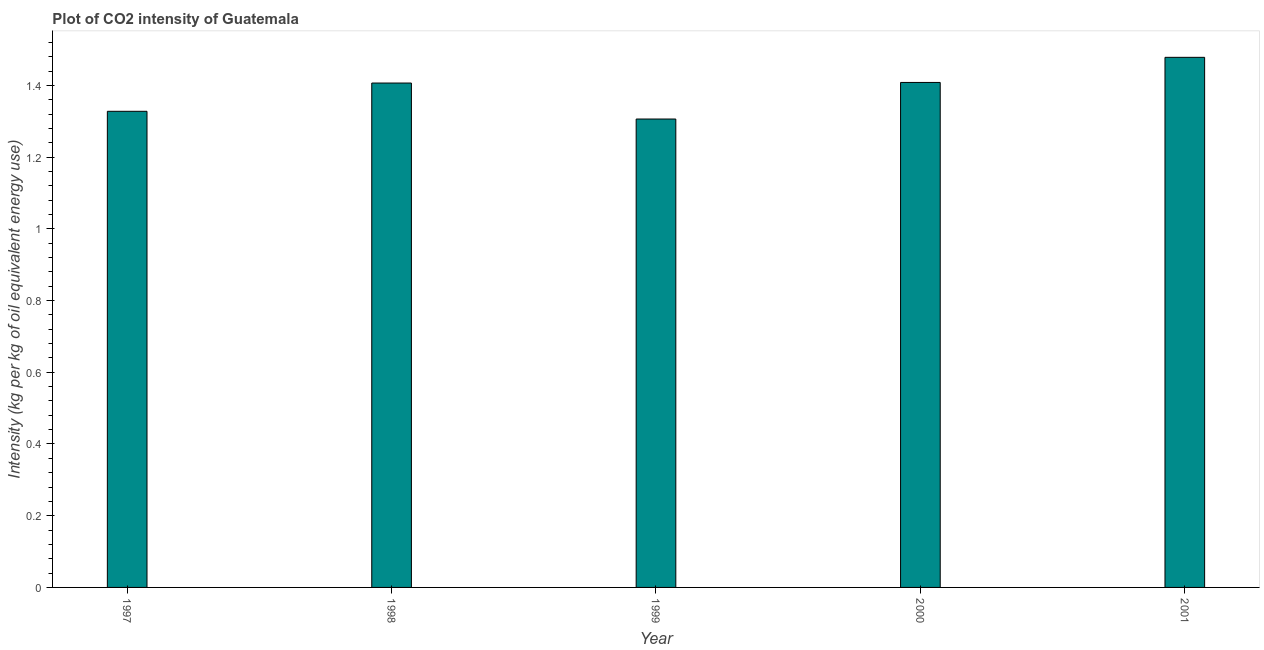Does the graph contain any zero values?
Provide a succinct answer. No. Does the graph contain grids?
Your answer should be compact. No. What is the title of the graph?
Your response must be concise. Plot of CO2 intensity of Guatemala. What is the label or title of the Y-axis?
Offer a very short reply. Intensity (kg per kg of oil equivalent energy use). What is the co2 intensity in 1997?
Ensure brevity in your answer.  1.33. Across all years, what is the maximum co2 intensity?
Your answer should be compact. 1.48. Across all years, what is the minimum co2 intensity?
Keep it short and to the point. 1.31. In which year was the co2 intensity maximum?
Provide a succinct answer. 2001. In which year was the co2 intensity minimum?
Provide a succinct answer. 1999. What is the sum of the co2 intensity?
Offer a very short reply. 6.93. What is the difference between the co2 intensity in 1998 and 2000?
Offer a terse response. -0. What is the average co2 intensity per year?
Your response must be concise. 1.39. What is the median co2 intensity?
Give a very brief answer. 1.41. In how many years, is the co2 intensity greater than 1.16 kg?
Offer a terse response. 5. Do a majority of the years between 2000 and 2001 (inclusive) have co2 intensity greater than 0.08 kg?
Make the answer very short. Yes. What is the ratio of the co2 intensity in 1998 to that in 2001?
Offer a very short reply. 0.95. What is the difference between the highest and the second highest co2 intensity?
Make the answer very short. 0.07. Is the sum of the co2 intensity in 2000 and 2001 greater than the maximum co2 intensity across all years?
Make the answer very short. Yes. What is the difference between the highest and the lowest co2 intensity?
Offer a very short reply. 0.17. How many bars are there?
Offer a very short reply. 5. How many years are there in the graph?
Ensure brevity in your answer.  5. Are the values on the major ticks of Y-axis written in scientific E-notation?
Offer a terse response. No. What is the Intensity (kg per kg of oil equivalent energy use) in 1997?
Offer a terse response. 1.33. What is the Intensity (kg per kg of oil equivalent energy use) in 1998?
Offer a terse response. 1.41. What is the Intensity (kg per kg of oil equivalent energy use) in 1999?
Offer a very short reply. 1.31. What is the Intensity (kg per kg of oil equivalent energy use) of 2000?
Keep it short and to the point. 1.41. What is the Intensity (kg per kg of oil equivalent energy use) in 2001?
Ensure brevity in your answer.  1.48. What is the difference between the Intensity (kg per kg of oil equivalent energy use) in 1997 and 1998?
Provide a short and direct response. -0.08. What is the difference between the Intensity (kg per kg of oil equivalent energy use) in 1997 and 1999?
Your answer should be very brief. 0.02. What is the difference between the Intensity (kg per kg of oil equivalent energy use) in 1997 and 2000?
Your answer should be compact. -0.08. What is the difference between the Intensity (kg per kg of oil equivalent energy use) in 1997 and 2001?
Your answer should be very brief. -0.15. What is the difference between the Intensity (kg per kg of oil equivalent energy use) in 1998 and 1999?
Your response must be concise. 0.1. What is the difference between the Intensity (kg per kg of oil equivalent energy use) in 1998 and 2000?
Your answer should be compact. -0. What is the difference between the Intensity (kg per kg of oil equivalent energy use) in 1998 and 2001?
Your answer should be very brief. -0.07. What is the difference between the Intensity (kg per kg of oil equivalent energy use) in 1999 and 2000?
Make the answer very short. -0.1. What is the difference between the Intensity (kg per kg of oil equivalent energy use) in 1999 and 2001?
Your answer should be very brief. -0.17. What is the difference between the Intensity (kg per kg of oil equivalent energy use) in 2000 and 2001?
Your answer should be very brief. -0.07. What is the ratio of the Intensity (kg per kg of oil equivalent energy use) in 1997 to that in 1998?
Your answer should be very brief. 0.94. What is the ratio of the Intensity (kg per kg of oil equivalent energy use) in 1997 to that in 1999?
Your answer should be compact. 1.02. What is the ratio of the Intensity (kg per kg of oil equivalent energy use) in 1997 to that in 2000?
Your answer should be very brief. 0.94. What is the ratio of the Intensity (kg per kg of oil equivalent energy use) in 1997 to that in 2001?
Provide a succinct answer. 0.9. What is the ratio of the Intensity (kg per kg of oil equivalent energy use) in 1998 to that in 1999?
Your answer should be compact. 1.08. What is the ratio of the Intensity (kg per kg of oil equivalent energy use) in 1998 to that in 2000?
Provide a succinct answer. 1. What is the ratio of the Intensity (kg per kg of oil equivalent energy use) in 1998 to that in 2001?
Offer a very short reply. 0.95. What is the ratio of the Intensity (kg per kg of oil equivalent energy use) in 1999 to that in 2000?
Offer a terse response. 0.93. What is the ratio of the Intensity (kg per kg of oil equivalent energy use) in 1999 to that in 2001?
Offer a very short reply. 0.88. What is the ratio of the Intensity (kg per kg of oil equivalent energy use) in 2000 to that in 2001?
Your answer should be compact. 0.95. 